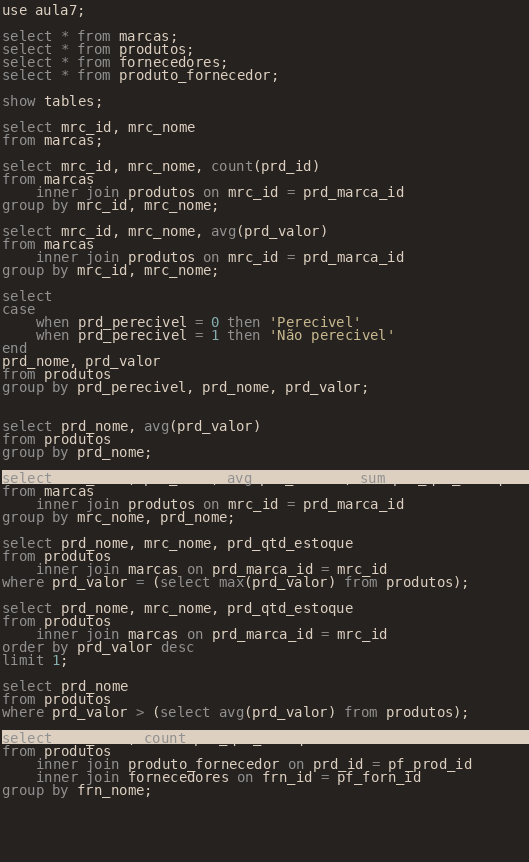<code> <loc_0><loc_0><loc_500><loc_500><_SQL_>use aula7;

select * from marcas;
select * from produtos;
select * from fornecedores;
select * from produto_fornecedor;

show tables;

select mrc_id, mrc_nome
from marcas;

select mrc_id, mrc_nome, count(prd_id)
from marcas
	inner join produtos on mrc_id = prd_marca_id
group by mrc_id, mrc_nome;

select mrc_id, mrc_nome, avg(prd_valor)
from marcas
	inner join produtos on mrc_id = prd_marca_id
group by mrc_id, mrc_nome;

select	
case 
	when prd_perecivel = 0 then 'Perecivel'
	when prd_perecivel = 1 then 'Não perecivel'
end
prd_nome, prd_valor
from produtos
group by prd_perecivel, prd_nome, prd_valor;


select prd_nome, avg(prd_valor)
from produtos
group by prd_nome;

select mrc_nome, prd_nome, avg(prd_valor), sum(prd_qtd_estoque)
from marcas
	inner join produtos on mrc_id = prd_marca_id
group by mrc_nome, prd_nome;

select prd_nome, mrc_nome, prd_qtd_estoque
from produtos 
	inner join marcas on prd_marca_id = mrc_id
where prd_valor = (select max(prd_valor) from produtos);

select prd_nome, mrc_nome, prd_qtd_estoque
from produtos 
	inner join marcas on prd_marca_id = mrc_id
order by prd_valor desc
limit 1;

select prd_nome
from produtos
where prd_valor > (select avg(prd_valor) from produtos);

select frn_nome, count(prd_qtd_estoque)
from produtos
	inner join produto_fornecedor on prd_id = pf_prod_id
	inner join fornecedores on frn_id = pf_forn_id
group by frn_nome;
	
	
	
	
	


</code> 